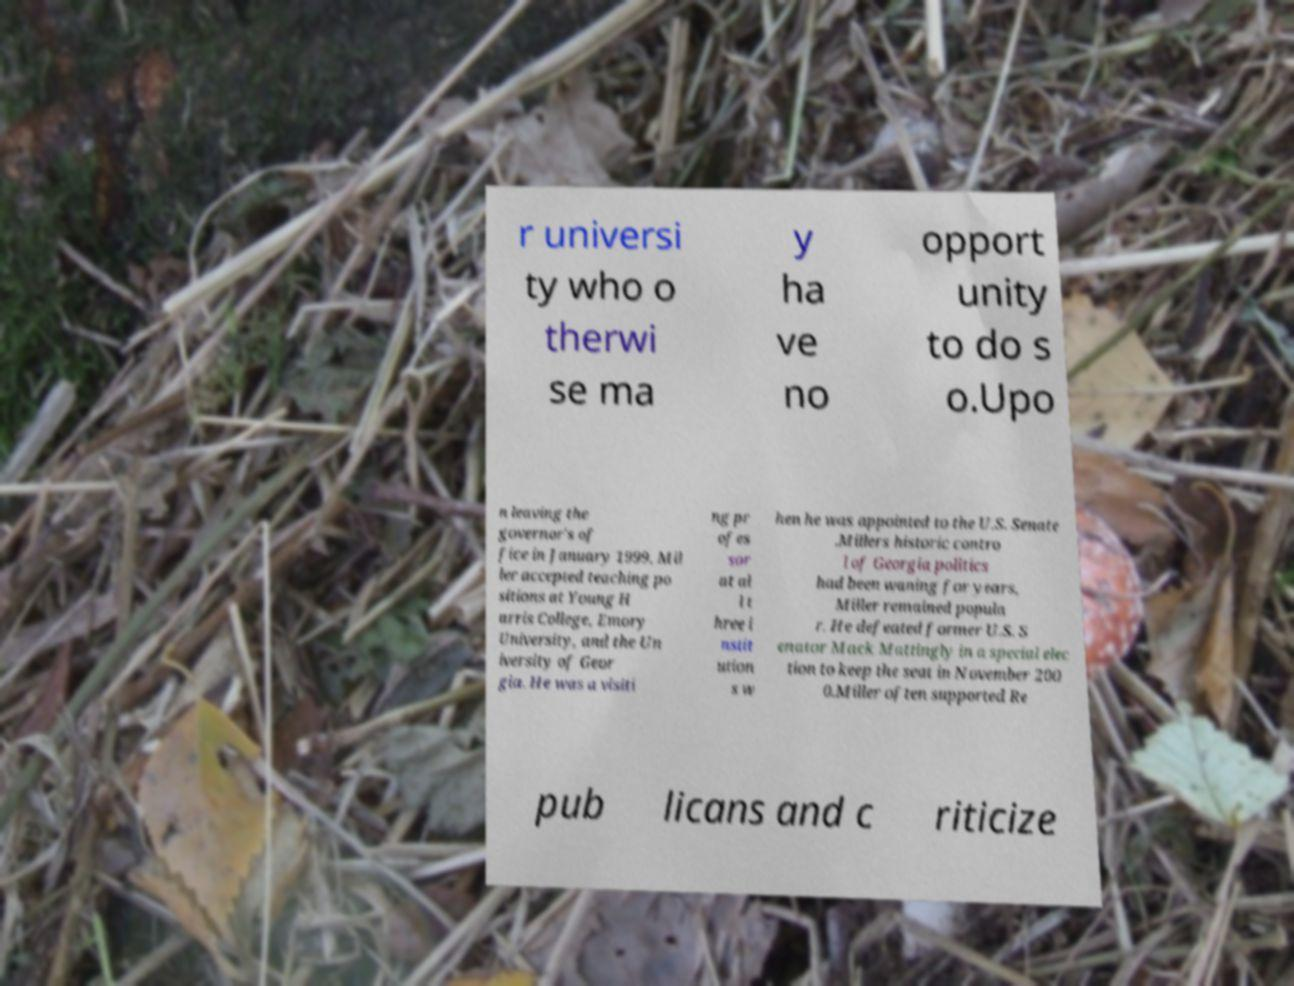Can you read and provide the text displayed in the image?This photo seems to have some interesting text. Can you extract and type it out for me? r universi ty who o therwi se ma y ha ve no opport unity to do s o.Upo n leaving the governor's of fice in January 1999, Mil ler accepted teaching po sitions at Young H arris College, Emory University, and the Un iversity of Geor gia. He was a visiti ng pr ofes sor at al l t hree i nstit ution s w hen he was appointed to the U.S. Senate .Millers historic contro l of Georgia politics had been waning for years, Miller remained popula r. He defeated former U.S. S enator Mack Mattingly in a special elec tion to keep the seat in November 200 0.Miller often supported Re pub licans and c riticize 